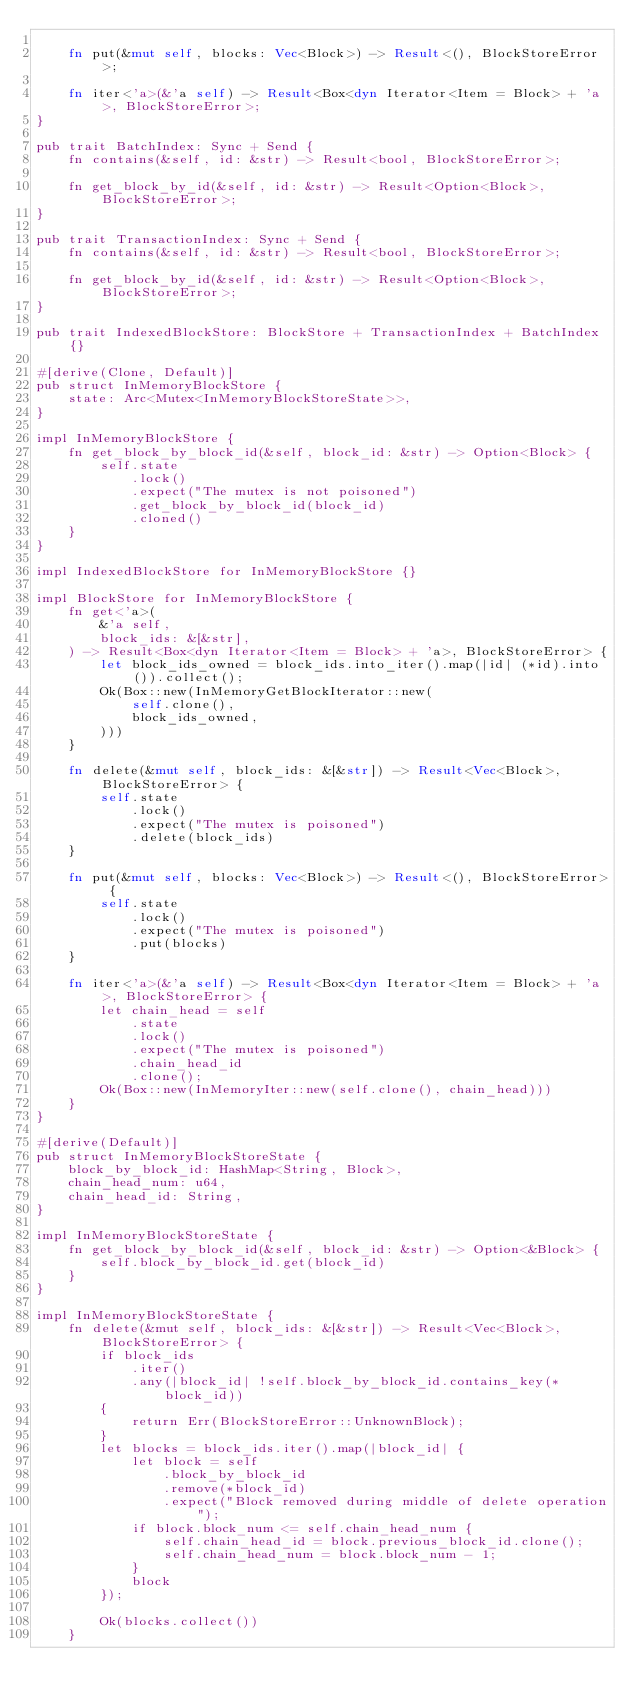<code> <loc_0><loc_0><loc_500><loc_500><_Rust_>
    fn put(&mut self, blocks: Vec<Block>) -> Result<(), BlockStoreError>;

    fn iter<'a>(&'a self) -> Result<Box<dyn Iterator<Item = Block> + 'a>, BlockStoreError>;
}

pub trait BatchIndex: Sync + Send {
    fn contains(&self, id: &str) -> Result<bool, BlockStoreError>;

    fn get_block_by_id(&self, id: &str) -> Result<Option<Block>, BlockStoreError>;
}

pub trait TransactionIndex: Sync + Send {
    fn contains(&self, id: &str) -> Result<bool, BlockStoreError>;

    fn get_block_by_id(&self, id: &str) -> Result<Option<Block>, BlockStoreError>;
}

pub trait IndexedBlockStore: BlockStore + TransactionIndex + BatchIndex {}

#[derive(Clone, Default)]
pub struct InMemoryBlockStore {
    state: Arc<Mutex<InMemoryBlockStoreState>>,
}

impl InMemoryBlockStore {
    fn get_block_by_block_id(&self, block_id: &str) -> Option<Block> {
        self.state
            .lock()
            .expect("The mutex is not poisoned")
            .get_block_by_block_id(block_id)
            .cloned()
    }
}

impl IndexedBlockStore for InMemoryBlockStore {}

impl BlockStore for InMemoryBlockStore {
    fn get<'a>(
        &'a self,
        block_ids: &[&str],
    ) -> Result<Box<dyn Iterator<Item = Block> + 'a>, BlockStoreError> {
        let block_ids_owned = block_ids.into_iter().map(|id| (*id).into()).collect();
        Ok(Box::new(InMemoryGetBlockIterator::new(
            self.clone(),
            block_ids_owned,
        )))
    }

    fn delete(&mut self, block_ids: &[&str]) -> Result<Vec<Block>, BlockStoreError> {
        self.state
            .lock()
            .expect("The mutex is poisoned")
            .delete(block_ids)
    }

    fn put(&mut self, blocks: Vec<Block>) -> Result<(), BlockStoreError> {
        self.state
            .lock()
            .expect("The mutex is poisoned")
            .put(blocks)
    }

    fn iter<'a>(&'a self) -> Result<Box<dyn Iterator<Item = Block> + 'a>, BlockStoreError> {
        let chain_head = self
            .state
            .lock()
            .expect("The mutex is poisoned")
            .chain_head_id
            .clone();
        Ok(Box::new(InMemoryIter::new(self.clone(), chain_head)))
    }
}

#[derive(Default)]
pub struct InMemoryBlockStoreState {
    block_by_block_id: HashMap<String, Block>,
    chain_head_num: u64,
    chain_head_id: String,
}

impl InMemoryBlockStoreState {
    fn get_block_by_block_id(&self, block_id: &str) -> Option<&Block> {
        self.block_by_block_id.get(block_id)
    }
}

impl InMemoryBlockStoreState {
    fn delete(&mut self, block_ids: &[&str]) -> Result<Vec<Block>, BlockStoreError> {
        if block_ids
            .iter()
            .any(|block_id| !self.block_by_block_id.contains_key(*block_id))
        {
            return Err(BlockStoreError::UnknownBlock);
        }
        let blocks = block_ids.iter().map(|block_id| {
            let block = self
                .block_by_block_id
                .remove(*block_id)
                .expect("Block removed during middle of delete operation");
            if block.block_num <= self.chain_head_num {
                self.chain_head_id = block.previous_block_id.clone();
                self.chain_head_num = block.block_num - 1;
            }
            block
        });

        Ok(blocks.collect())
    }
</code> 